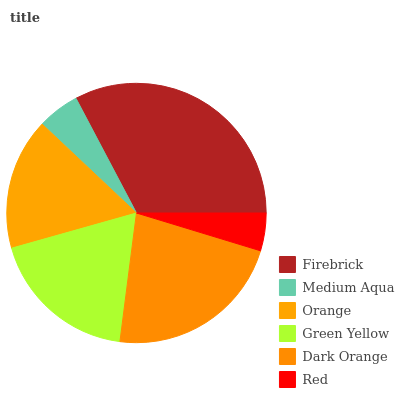Is Red the minimum?
Answer yes or no. Yes. Is Firebrick the maximum?
Answer yes or no. Yes. Is Medium Aqua the minimum?
Answer yes or no. No. Is Medium Aqua the maximum?
Answer yes or no. No. Is Firebrick greater than Medium Aqua?
Answer yes or no. Yes. Is Medium Aqua less than Firebrick?
Answer yes or no. Yes. Is Medium Aqua greater than Firebrick?
Answer yes or no. No. Is Firebrick less than Medium Aqua?
Answer yes or no. No. Is Green Yellow the high median?
Answer yes or no. Yes. Is Orange the low median?
Answer yes or no. Yes. Is Medium Aqua the high median?
Answer yes or no. No. Is Red the low median?
Answer yes or no. No. 